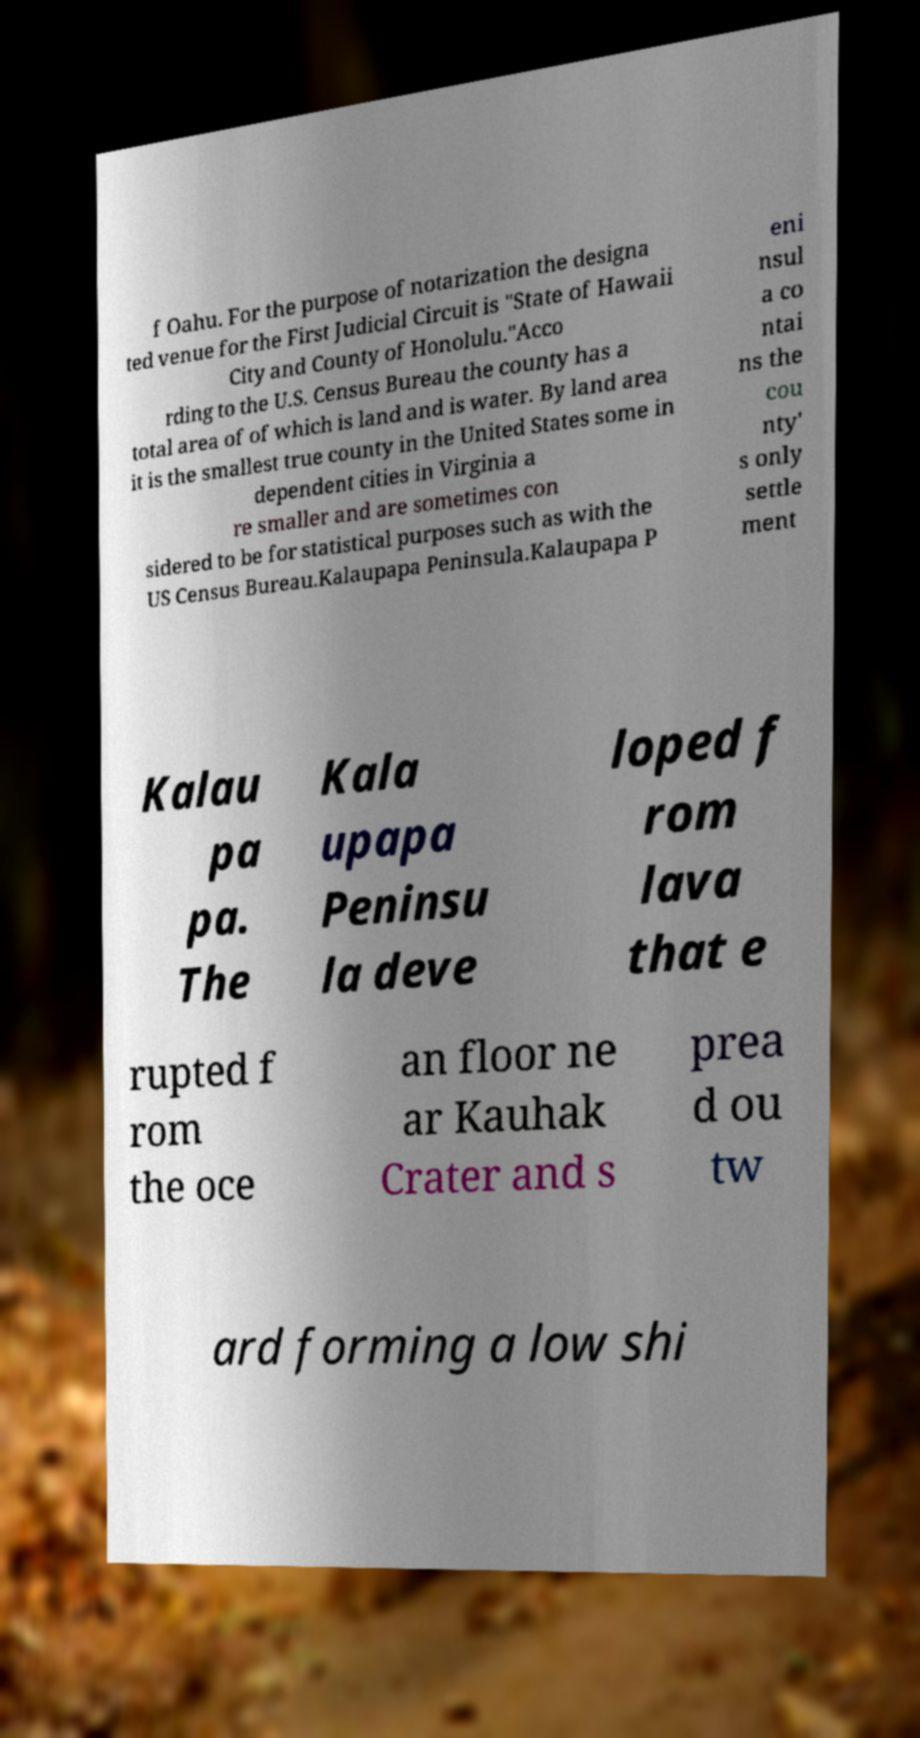Could you assist in decoding the text presented in this image and type it out clearly? f Oahu. For the purpose of notarization the designa ted venue for the First Judicial Circuit is "State of Hawaii City and County of Honolulu."Acco rding to the U.S. Census Bureau the county has a total area of of which is land and is water. By land area it is the smallest true county in the United States some in dependent cities in Virginia a re smaller and are sometimes con sidered to be for statistical purposes such as with the US Census Bureau.Kalaupapa Peninsula.Kalaupapa P eni nsul a co ntai ns the cou nty' s only settle ment Kalau pa pa. The Kala upapa Peninsu la deve loped f rom lava that e rupted f rom the oce an floor ne ar Kauhak Crater and s prea d ou tw ard forming a low shi 